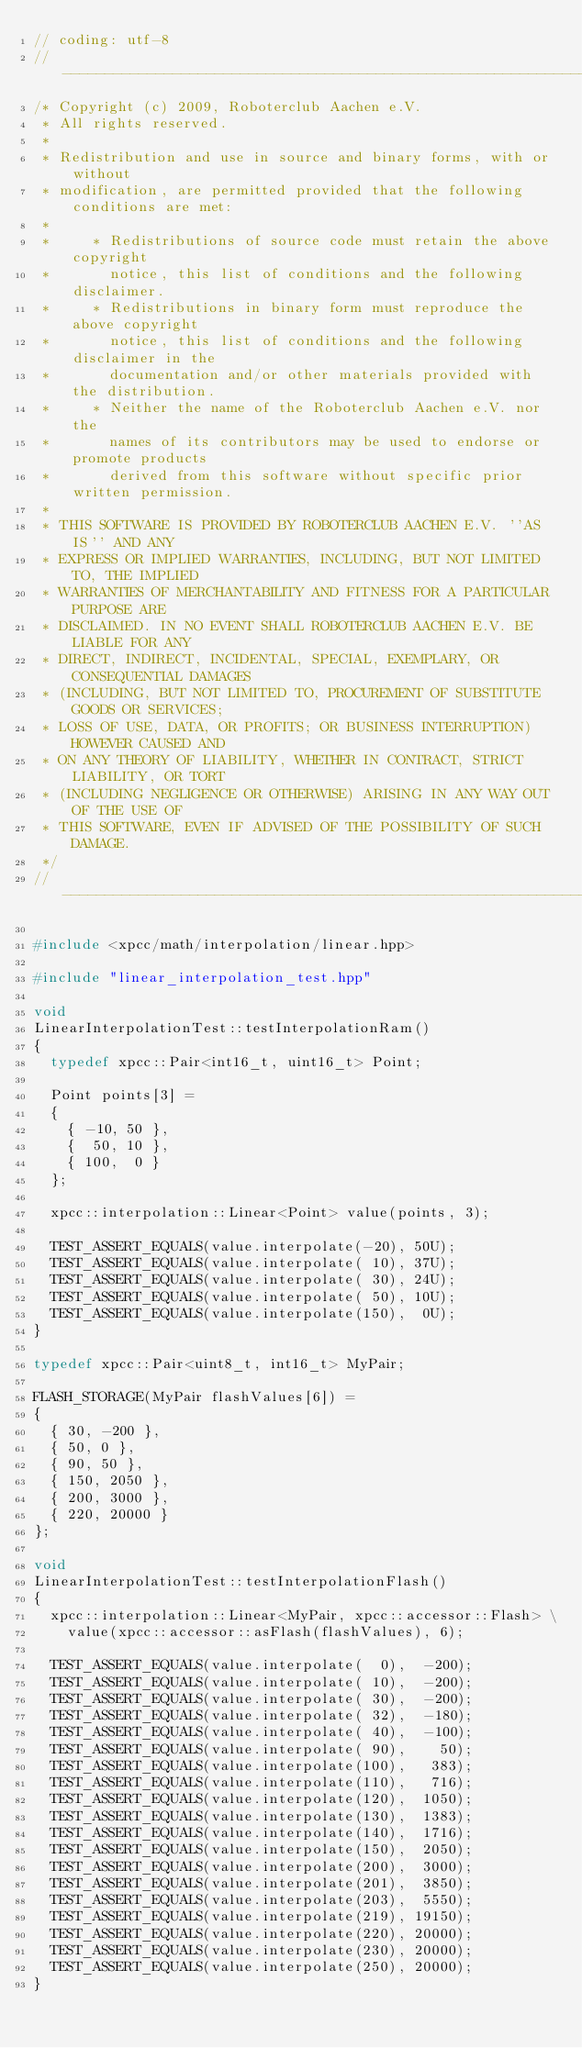Convert code to text. <code><loc_0><loc_0><loc_500><loc_500><_C++_>// coding: utf-8
// ----------------------------------------------------------------------------
/* Copyright (c) 2009, Roboterclub Aachen e.V.
 * All rights reserved.
 *
 * Redistribution and use in source and binary forms, with or without
 * modification, are permitted provided that the following conditions are met:
 *
 *     * Redistributions of source code must retain the above copyright
 *       notice, this list of conditions and the following disclaimer.
 *     * Redistributions in binary form must reproduce the above copyright
 *       notice, this list of conditions and the following disclaimer in the
 *       documentation and/or other materials provided with the distribution.
 *     * Neither the name of the Roboterclub Aachen e.V. nor the
 *       names of its contributors may be used to endorse or promote products
 *       derived from this software without specific prior written permission.
 *
 * THIS SOFTWARE IS PROVIDED BY ROBOTERCLUB AACHEN E.V. ''AS IS'' AND ANY
 * EXPRESS OR IMPLIED WARRANTIES, INCLUDING, BUT NOT LIMITED TO, THE IMPLIED
 * WARRANTIES OF MERCHANTABILITY AND FITNESS FOR A PARTICULAR PURPOSE ARE
 * DISCLAIMED. IN NO EVENT SHALL ROBOTERCLUB AACHEN E.V. BE LIABLE FOR ANY
 * DIRECT, INDIRECT, INCIDENTAL, SPECIAL, EXEMPLARY, OR CONSEQUENTIAL DAMAGES
 * (INCLUDING, BUT NOT LIMITED TO, PROCUREMENT OF SUBSTITUTE GOODS OR SERVICES;
 * LOSS OF USE, DATA, OR PROFITS; OR BUSINESS INTERRUPTION) HOWEVER CAUSED AND
 * ON ANY THEORY OF LIABILITY, WHETHER IN CONTRACT, STRICT LIABILITY, OR TORT
 * (INCLUDING NEGLIGENCE OR OTHERWISE) ARISING IN ANY WAY OUT OF THE USE OF
 * THIS SOFTWARE, EVEN IF ADVISED OF THE POSSIBILITY OF SUCH DAMAGE.
 */
// ----------------------------------------------------------------------------

#include <xpcc/math/interpolation/linear.hpp>

#include "linear_interpolation_test.hpp"

void
LinearInterpolationTest::testInterpolationRam()
{
	typedef xpcc::Pair<int16_t, uint16_t> Point;
	
	Point points[3] =
	{
		{ -10, 50 },
		{  50, 10 },
		{ 100,  0 }
	};
	
	xpcc::interpolation::Linear<Point> value(points, 3);
	
	TEST_ASSERT_EQUALS(value.interpolate(-20), 50U);
	TEST_ASSERT_EQUALS(value.interpolate( 10), 37U);
	TEST_ASSERT_EQUALS(value.interpolate( 30), 24U);
	TEST_ASSERT_EQUALS(value.interpolate( 50), 10U);
	TEST_ASSERT_EQUALS(value.interpolate(150),  0U);
}

typedef xpcc::Pair<uint8_t, int16_t> MyPair;

FLASH_STORAGE(MyPair flashValues[6]) =
{
	{ 30, -200 },
	{ 50, 0 },
	{ 90, 50 },
	{ 150, 2050 },
	{ 200, 3000 },
	{ 220, 20000 }
};

void 
LinearInterpolationTest::testInterpolationFlash()
{
	xpcc::interpolation::Linear<MyPair, xpcc::accessor::Flash> \
		value(xpcc::accessor::asFlash(flashValues), 6);
	
	TEST_ASSERT_EQUALS(value.interpolate(  0),  -200);
	TEST_ASSERT_EQUALS(value.interpolate( 10),  -200);
	TEST_ASSERT_EQUALS(value.interpolate( 30),  -200);
	TEST_ASSERT_EQUALS(value.interpolate( 32),  -180);
	TEST_ASSERT_EQUALS(value.interpolate( 40),  -100);
	TEST_ASSERT_EQUALS(value.interpolate( 90),    50);
	TEST_ASSERT_EQUALS(value.interpolate(100),   383);
	TEST_ASSERT_EQUALS(value.interpolate(110),   716);
	TEST_ASSERT_EQUALS(value.interpolate(120),  1050);
	TEST_ASSERT_EQUALS(value.interpolate(130),  1383);
	TEST_ASSERT_EQUALS(value.interpolate(140),  1716);
	TEST_ASSERT_EQUALS(value.interpolate(150),  2050);
	TEST_ASSERT_EQUALS(value.interpolate(200),  3000);
	TEST_ASSERT_EQUALS(value.interpolate(201),  3850);
	TEST_ASSERT_EQUALS(value.interpolate(203),  5550);
	TEST_ASSERT_EQUALS(value.interpolate(219), 19150);
	TEST_ASSERT_EQUALS(value.interpolate(220), 20000);
	TEST_ASSERT_EQUALS(value.interpolate(230), 20000);
	TEST_ASSERT_EQUALS(value.interpolate(250), 20000);
}
</code> 